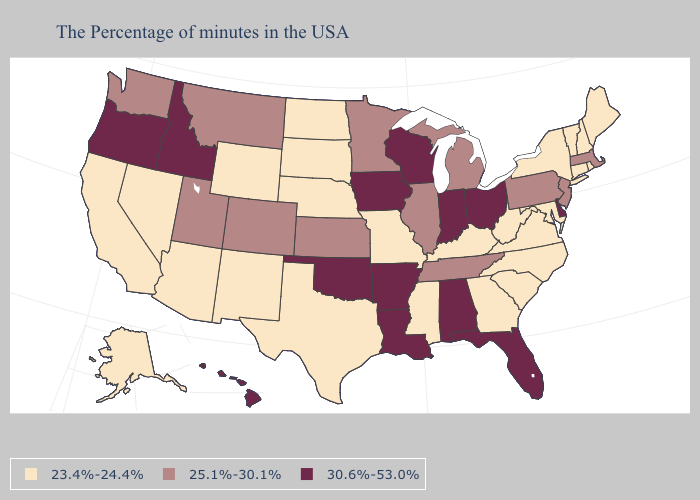Is the legend a continuous bar?
Answer briefly. No. What is the value of Illinois?
Answer briefly. 25.1%-30.1%. Does New York have the same value as Massachusetts?
Give a very brief answer. No. Does the first symbol in the legend represent the smallest category?
Concise answer only. Yes. What is the highest value in states that border Indiana?
Quick response, please. 30.6%-53.0%. What is the highest value in the South ?
Give a very brief answer. 30.6%-53.0%. Among the states that border Utah , does New Mexico have the highest value?
Write a very short answer. No. How many symbols are there in the legend?
Concise answer only. 3. What is the highest value in the USA?
Short answer required. 30.6%-53.0%. Which states have the lowest value in the USA?
Write a very short answer. Maine, Rhode Island, New Hampshire, Vermont, Connecticut, New York, Maryland, Virginia, North Carolina, South Carolina, West Virginia, Georgia, Kentucky, Mississippi, Missouri, Nebraska, Texas, South Dakota, North Dakota, Wyoming, New Mexico, Arizona, Nevada, California, Alaska. Does the first symbol in the legend represent the smallest category?
Be succinct. Yes. Does Oklahoma have the lowest value in the South?
Answer briefly. No. Does South Carolina have the highest value in the USA?
Concise answer only. No. What is the lowest value in the West?
Answer briefly. 23.4%-24.4%. Does Missouri have the lowest value in the USA?
Concise answer only. Yes. 